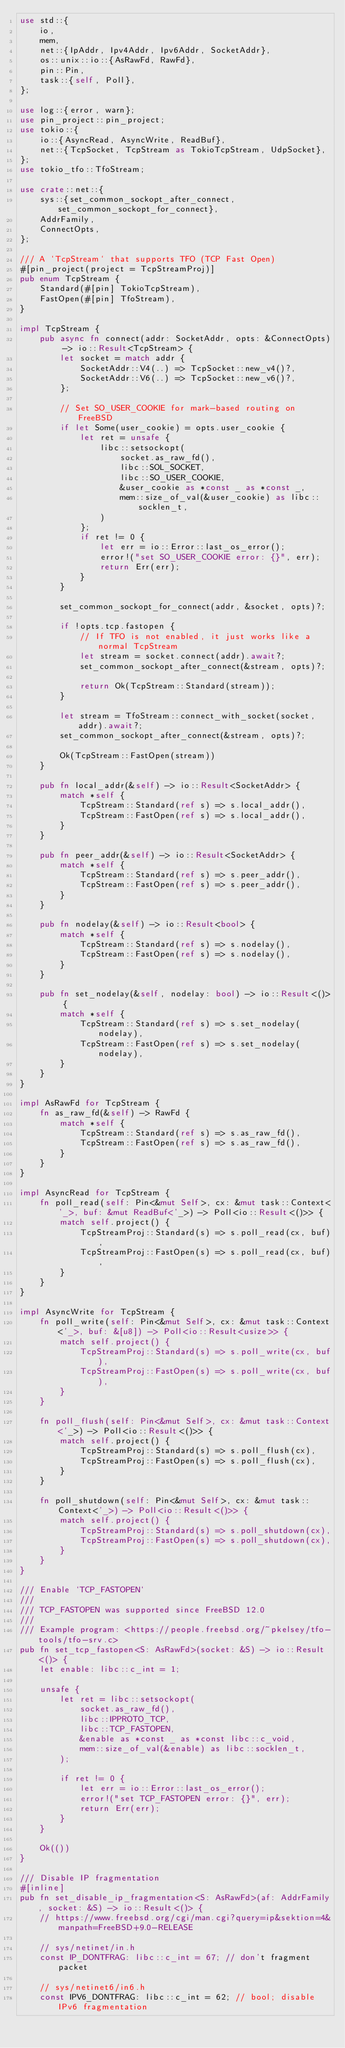<code> <loc_0><loc_0><loc_500><loc_500><_Rust_>use std::{
    io,
    mem,
    net::{IpAddr, Ipv4Addr, Ipv6Addr, SocketAddr},
    os::unix::io::{AsRawFd, RawFd},
    pin::Pin,
    task::{self, Poll},
};

use log::{error, warn};
use pin_project::pin_project;
use tokio::{
    io::{AsyncRead, AsyncWrite, ReadBuf},
    net::{TcpSocket, TcpStream as TokioTcpStream, UdpSocket},
};
use tokio_tfo::TfoStream;

use crate::net::{
    sys::{set_common_sockopt_after_connect, set_common_sockopt_for_connect},
    AddrFamily,
    ConnectOpts,
};

/// A `TcpStream` that supports TFO (TCP Fast Open)
#[pin_project(project = TcpStreamProj)]
pub enum TcpStream {
    Standard(#[pin] TokioTcpStream),
    FastOpen(#[pin] TfoStream),
}

impl TcpStream {
    pub async fn connect(addr: SocketAddr, opts: &ConnectOpts) -> io::Result<TcpStream> {
        let socket = match addr {
            SocketAddr::V4(..) => TcpSocket::new_v4()?,
            SocketAddr::V6(..) => TcpSocket::new_v6()?,
        };

        // Set SO_USER_COOKIE for mark-based routing on FreeBSD
        if let Some(user_cookie) = opts.user_cookie {
            let ret = unsafe {
                libc::setsockopt(
                    socket.as_raw_fd(),
                    libc::SOL_SOCKET,
                    libc::SO_USER_COOKIE,
                    &user_cookie as *const _ as *const _,
                    mem::size_of_val(&user_cookie) as libc::socklen_t,
                )
            };
            if ret != 0 {
                let err = io::Error::last_os_error();
                error!("set SO_USER_COOKIE error: {}", err);
                return Err(err);
            }
        }

        set_common_sockopt_for_connect(addr, &socket, opts)?;

        if !opts.tcp.fastopen {
            // If TFO is not enabled, it just works like a normal TcpStream
            let stream = socket.connect(addr).await?;
            set_common_sockopt_after_connect(&stream, opts)?;

            return Ok(TcpStream::Standard(stream));
        }

        let stream = TfoStream::connect_with_socket(socket, addr).await?;
        set_common_sockopt_after_connect(&stream, opts)?;

        Ok(TcpStream::FastOpen(stream))
    }

    pub fn local_addr(&self) -> io::Result<SocketAddr> {
        match *self {
            TcpStream::Standard(ref s) => s.local_addr(),
            TcpStream::FastOpen(ref s) => s.local_addr(),
        }
    }

    pub fn peer_addr(&self) -> io::Result<SocketAddr> {
        match *self {
            TcpStream::Standard(ref s) => s.peer_addr(),
            TcpStream::FastOpen(ref s) => s.peer_addr(),
        }
    }

    pub fn nodelay(&self) -> io::Result<bool> {
        match *self {
            TcpStream::Standard(ref s) => s.nodelay(),
            TcpStream::FastOpen(ref s) => s.nodelay(),
        }
    }

    pub fn set_nodelay(&self, nodelay: bool) -> io::Result<()> {
        match *self {
            TcpStream::Standard(ref s) => s.set_nodelay(nodelay),
            TcpStream::FastOpen(ref s) => s.set_nodelay(nodelay),
        }
    }
}

impl AsRawFd for TcpStream {
    fn as_raw_fd(&self) -> RawFd {
        match *self {
            TcpStream::Standard(ref s) => s.as_raw_fd(),
            TcpStream::FastOpen(ref s) => s.as_raw_fd(),
        }
    }
}

impl AsyncRead for TcpStream {
    fn poll_read(self: Pin<&mut Self>, cx: &mut task::Context<'_>, buf: &mut ReadBuf<'_>) -> Poll<io::Result<()>> {
        match self.project() {
            TcpStreamProj::Standard(s) => s.poll_read(cx, buf),
            TcpStreamProj::FastOpen(s) => s.poll_read(cx, buf),
        }
    }
}

impl AsyncWrite for TcpStream {
    fn poll_write(self: Pin<&mut Self>, cx: &mut task::Context<'_>, buf: &[u8]) -> Poll<io::Result<usize>> {
        match self.project() {
            TcpStreamProj::Standard(s) => s.poll_write(cx, buf),
            TcpStreamProj::FastOpen(s) => s.poll_write(cx, buf),
        }
    }

    fn poll_flush(self: Pin<&mut Self>, cx: &mut task::Context<'_>) -> Poll<io::Result<()>> {
        match self.project() {
            TcpStreamProj::Standard(s) => s.poll_flush(cx),
            TcpStreamProj::FastOpen(s) => s.poll_flush(cx),
        }
    }

    fn poll_shutdown(self: Pin<&mut Self>, cx: &mut task::Context<'_>) -> Poll<io::Result<()>> {
        match self.project() {
            TcpStreamProj::Standard(s) => s.poll_shutdown(cx),
            TcpStreamProj::FastOpen(s) => s.poll_shutdown(cx),
        }
    }
}

/// Enable `TCP_FASTOPEN`
///
/// TCP_FASTOPEN was supported since FreeBSD 12.0
///
/// Example program: <https://people.freebsd.org/~pkelsey/tfo-tools/tfo-srv.c>
pub fn set_tcp_fastopen<S: AsRawFd>(socket: &S) -> io::Result<()> {
    let enable: libc::c_int = 1;

    unsafe {
        let ret = libc::setsockopt(
            socket.as_raw_fd(),
            libc::IPPROTO_TCP,
            libc::TCP_FASTOPEN,
            &enable as *const _ as *const libc::c_void,
            mem::size_of_val(&enable) as libc::socklen_t,
        );

        if ret != 0 {
            let err = io::Error::last_os_error();
            error!("set TCP_FASTOPEN error: {}", err);
            return Err(err);
        }
    }

    Ok(())
}

/// Disable IP fragmentation
#[inline]
pub fn set_disable_ip_fragmentation<S: AsRawFd>(af: AddrFamily, socket: &S) -> io::Result<()> {
    // https://www.freebsd.org/cgi/man.cgi?query=ip&sektion=4&manpath=FreeBSD+9.0-RELEASE

    // sys/netinet/in.h
    const IP_DONTFRAG: libc::c_int = 67; // don't fragment packet

    // sys/netinet6/in6.h
    const IPV6_DONTFRAG: libc::c_int = 62; // bool; disable IPv6 fragmentation
</code> 